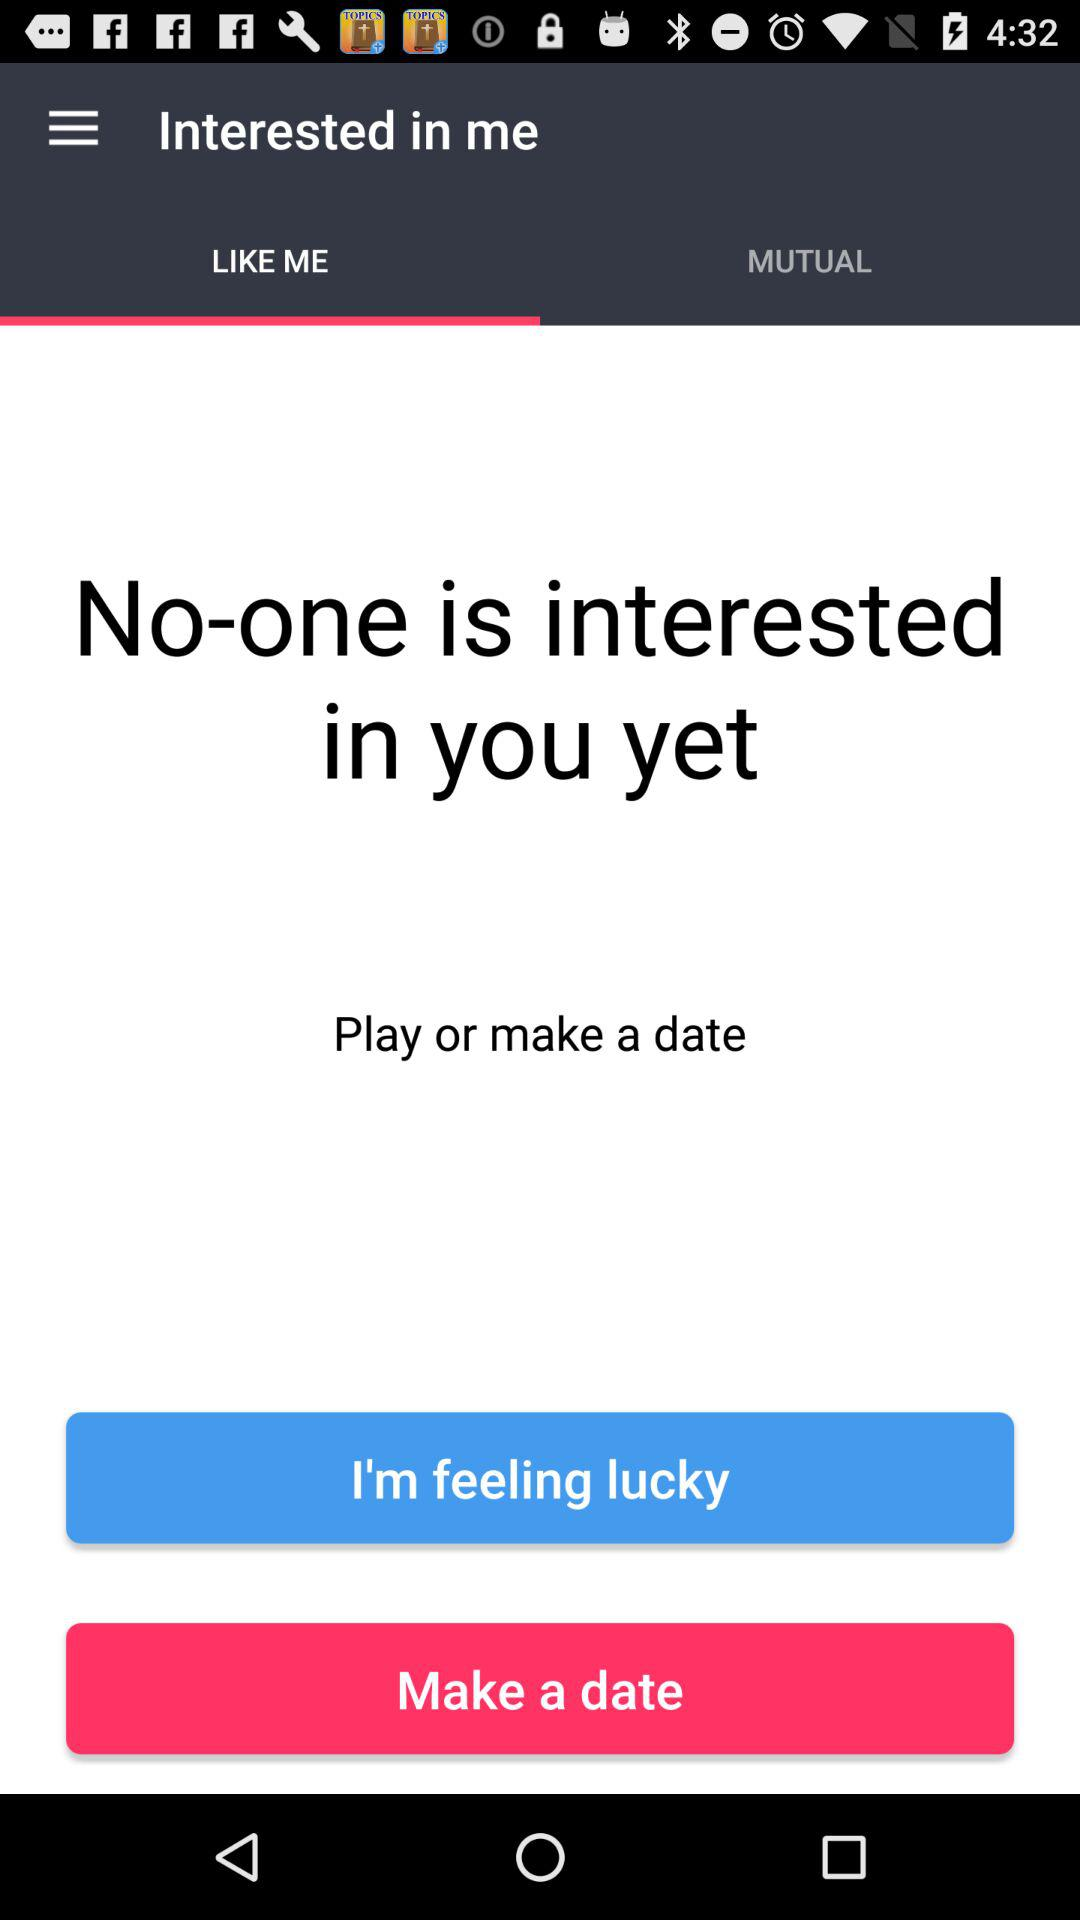What is the application name?
When the provided information is insufficient, respond with <no answer>. <no answer> 